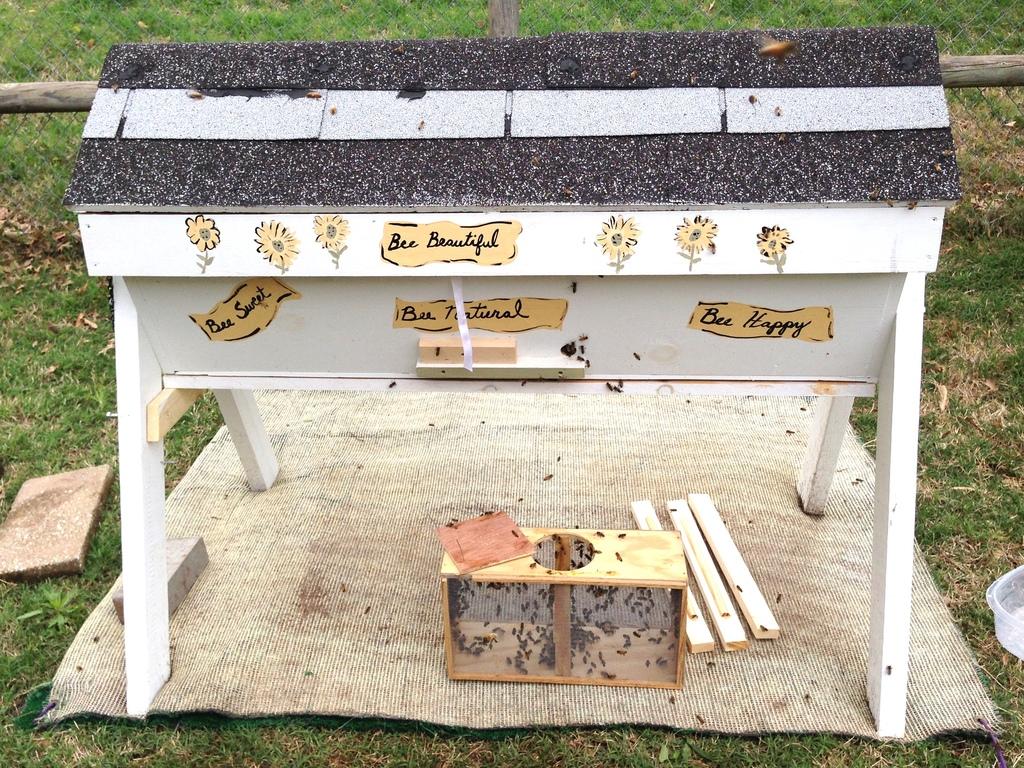What word do all the signs start with?
Provide a succinct answer. Bee. 